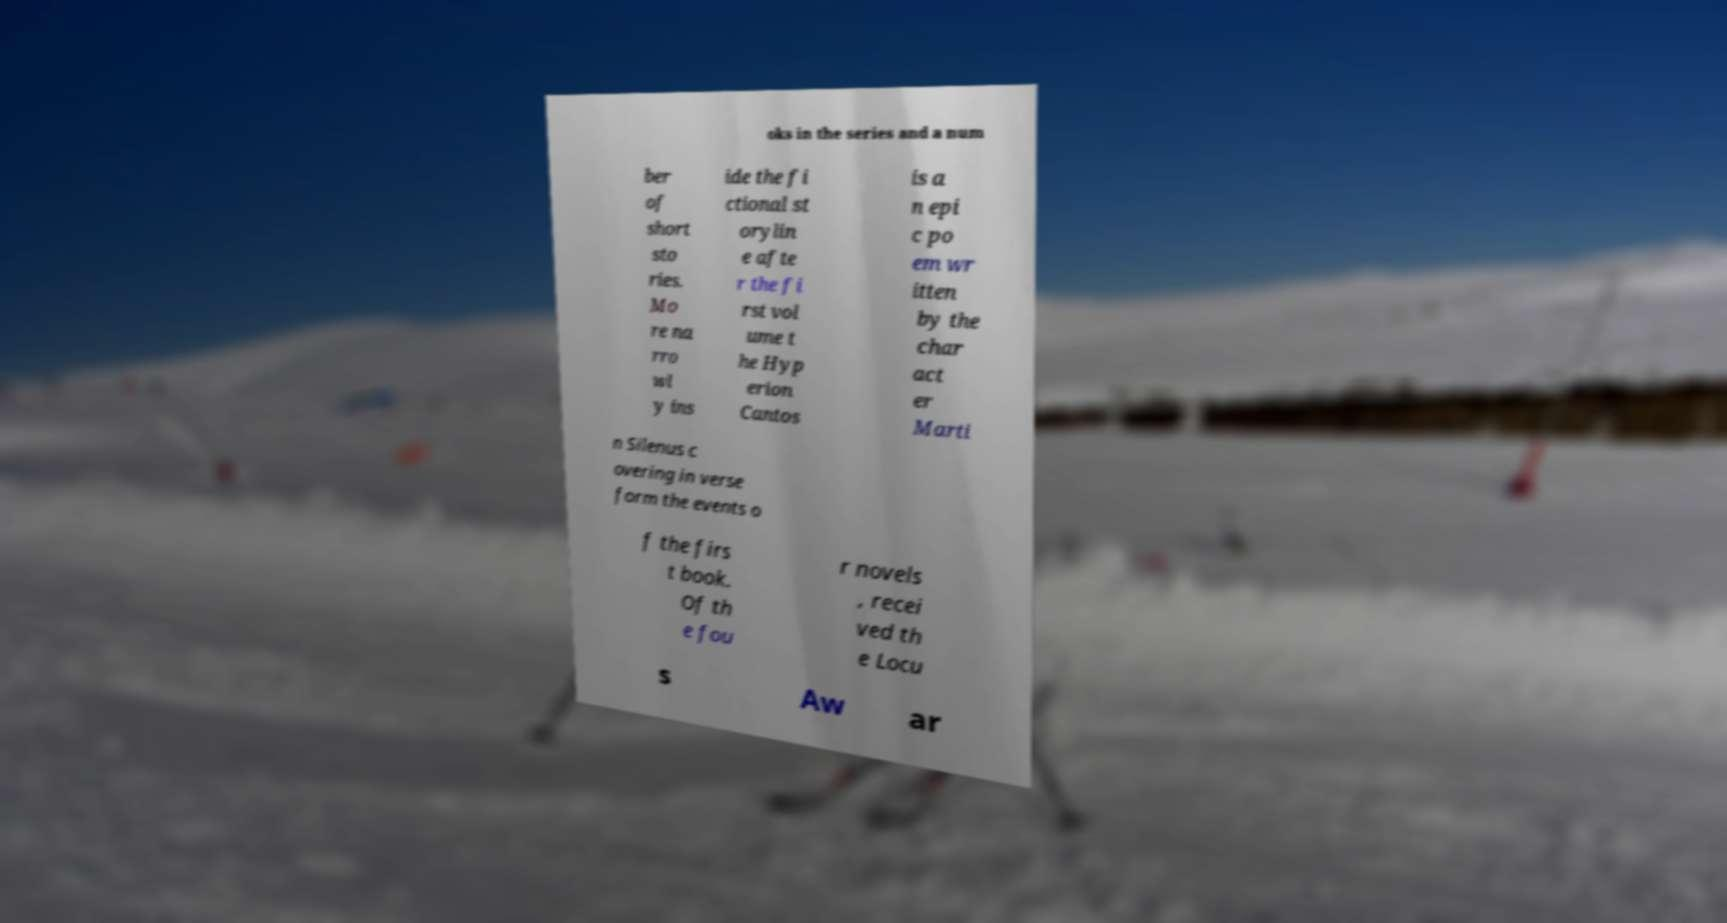Can you read and provide the text displayed in the image?This photo seems to have some interesting text. Can you extract and type it out for me? oks in the series and a num ber of short sto ries. Mo re na rro wl y ins ide the fi ctional st orylin e afte r the fi rst vol ume t he Hyp erion Cantos is a n epi c po em wr itten by the char act er Marti n Silenus c overing in verse form the events o f the firs t book. Of th e fou r novels , recei ved th e Locu s Aw ar 